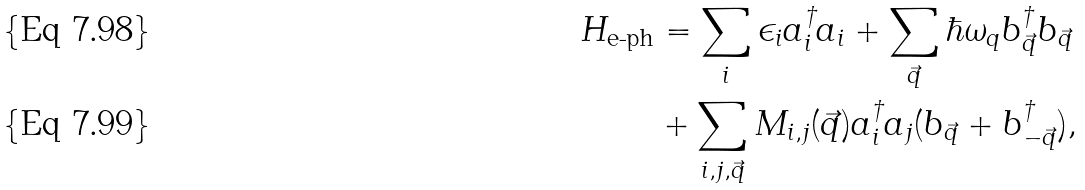Convert formula to latex. <formula><loc_0><loc_0><loc_500><loc_500>H _ { \text {e-ph} } & = \sum _ { i } \epsilon _ { i } a ^ { \dagger } _ { i } a _ { i } + \sum _ { \vec { q } } \hbar { \omega } _ { q } b ^ { \dagger } _ { \vec { q } } b _ { \vec { q } } \\ & + \sum _ { i , j , \vec { q } } M _ { i , j } ( \vec { q } ) a ^ { \dagger } _ { i } a _ { j } ( b _ { \vec { q } } + b ^ { \dagger } _ { - \vec { q } } ) ,</formula> 